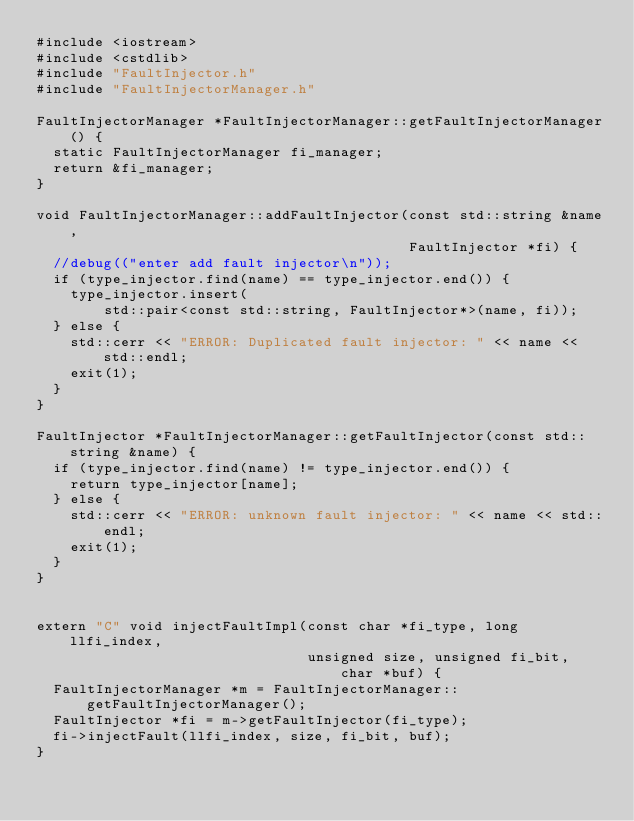<code> <loc_0><loc_0><loc_500><loc_500><_C++_>#include <iostream>
#include <cstdlib>
#include "FaultInjector.h"
#include "FaultInjectorManager.h"

FaultInjectorManager *FaultInjectorManager::getFaultInjectorManager() {
  static FaultInjectorManager fi_manager;
  return &fi_manager;
}

void FaultInjectorManager::addFaultInjector(const std::string &name,
                                            FaultInjector *fi) {
  //debug(("enter add fault injector\n"));
  if (type_injector.find(name) == type_injector.end()) {
    type_injector.insert(
        std::pair<const std::string, FaultInjector*>(name, fi));
  } else {
    std::cerr << "ERROR: Duplicated fault injector: " << name << std::endl;
    exit(1);
  }
}

FaultInjector *FaultInjectorManager::getFaultInjector(const std::string &name) {
  if (type_injector.find(name) != type_injector.end()) {
    return type_injector[name];
  } else {
    std::cerr << "ERROR: unknown fault injector: " << name << std::endl;
    exit(1);
  }
}


extern "C" void injectFaultImpl(const char *fi_type, long llfi_index, 
                                unsigned size, unsigned fi_bit, char *buf) {
  FaultInjectorManager *m = FaultInjectorManager::getFaultInjectorManager();
  FaultInjector *fi = m->getFaultInjector(fi_type);
  fi->injectFault(llfi_index, size, fi_bit, buf);
}
</code> 